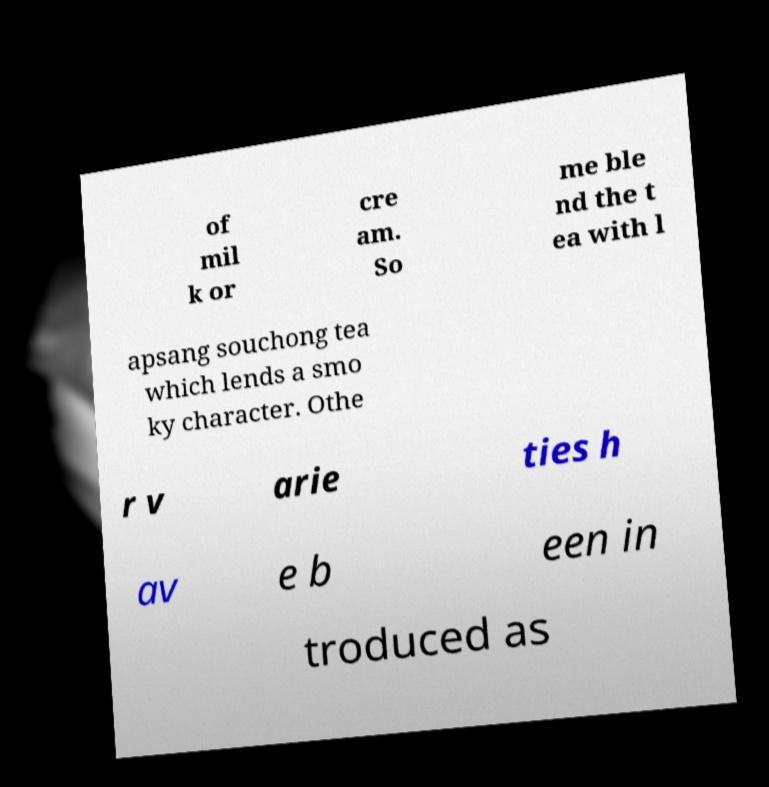Could you assist in decoding the text presented in this image and type it out clearly? of mil k or cre am. So me ble nd the t ea with l apsang souchong tea which lends a smo ky character. Othe r v arie ties h av e b een in troduced as 